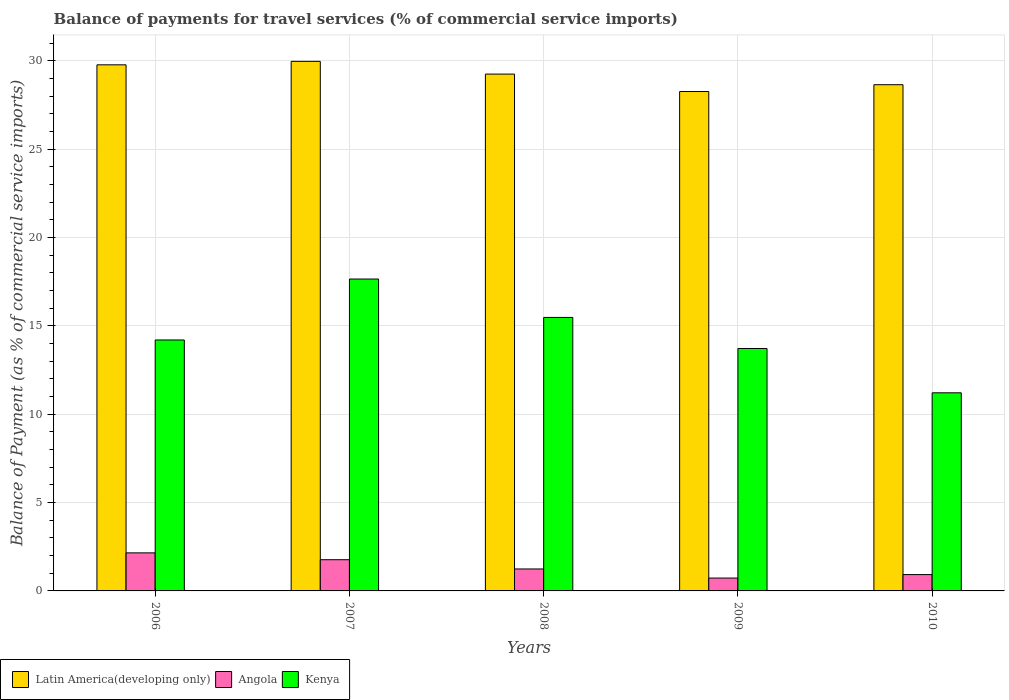Are the number of bars per tick equal to the number of legend labels?
Your answer should be very brief. Yes. Are the number of bars on each tick of the X-axis equal?
Your response must be concise. Yes. How many bars are there on the 2nd tick from the right?
Provide a short and direct response. 3. What is the label of the 1st group of bars from the left?
Your answer should be compact. 2006. What is the balance of payments for travel services in Kenya in 2008?
Provide a short and direct response. 15.48. Across all years, what is the maximum balance of payments for travel services in Angola?
Your answer should be very brief. 2.15. Across all years, what is the minimum balance of payments for travel services in Latin America(developing only)?
Ensure brevity in your answer.  28.26. What is the total balance of payments for travel services in Angola in the graph?
Ensure brevity in your answer.  6.81. What is the difference between the balance of payments for travel services in Angola in 2008 and that in 2009?
Give a very brief answer. 0.51. What is the difference between the balance of payments for travel services in Latin America(developing only) in 2008 and the balance of payments for travel services in Kenya in 2010?
Your response must be concise. 18.04. What is the average balance of payments for travel services in Kenya per year?
Offer a very short reply. 14.45. In the year 2009, what is the difference between the balance of payments for travel services in Angola and balance of payments for travel services in Kenya?
Keep it short and to the point. -12.99. What is the ratio of the balance of payments for travel services in Angola in 2006 to that in 2008?
Keep it short and to the point. 1.73. Is the difference between the balance of payments for travel services in Angola in 2006 and 2009 greater than the difference between the balance of payments for travel services in Kenya in 2006 and 2009?
Ensure brevity in your answer.  Yes. What is the difference between the highest and the second highest balance of payments for travel services in Latin America(developing only)?
Offer a very short reply. 0.2. What is the difference between the highest and the lowest balance of payments for travel services in Kenya?
Keep it short and to the point. 6.44. In how many years, is the balance of payments for travel services in Kenya greater than the average balance of payments for travel services in Kenya taken over all years?
Offer a very short reply. 2. Is the sum of the balance of payments for travel services in Latin America(developing only) in 2006 and 2010 greater than the maximum balance of payments for travel services in Angola across all years?
Keep it short and to the point. Yes. What does the 3rd bar from the left in 2009 represents?
Your response must be concise. Kenya. What does the 3rd bar from the right in 2008 represents?
Ensure brevity in your answer.  Latin America(developing only). Are all the bars in the graph horizontal?
Give a very brief answer. No. Are the values on the major ticks of Y-axis written in scientific E-notation?
Keep it short and to the point. No. Does the graph contain grids?
Your answer should be very brief. Yes. How many legend labels are there?
Ensure brevity in your answer.  3. How are the legend labels stacked?
Make the answer very short. Horizontal. What is the title of the graph?
Ensure brevity in your answer.  Balance of payments for travel services (% of commercial service imports). Does "Equatorial Guinea" appear as one of the legend labels in the graph?
Offer a terse response. No. What is the label or title of the X-axis?
Offer a very short reply. Years. What is the label or title of the Y-axis?
Offer a very short reply. Balance of Payment (as % of commercial service imports). What is the Balance of Payment (as % of commercial service imports) in Latin America(developing only) in 2006?
Ensure brevity in your answer.  29.77. What is the Balance of Payment (as % of commercial service imports) of Angola in 2006?
Offer a very short reply. 2.15. What is the Balance of Payment (as % of commercial service imports) of Kenya in 2006?
Provide a short and direct response. 14.2. What is the Balance of Payment (as % of commercial service imports) in Latin America(developing only) in 2007?
Your answer should be very brief. 29.97. What is the Balance of Payment (as % of commercial service imports) of Angola in 2007?
Offer a very short reply. 1.77. What is the Balance of Payment (as % of commercial service imports) in Kenya in 2007?
Keep it short and to the point. 17.65. What is the Balance of Payment (as % of commercial service imports) in Latin America(developing only) in 2008?
Your response must be concise. 29.25. What is the Balance of Payment (as % of commercial service imports) in Angola in 2008?
Provide a succinct answer. 1.24. What is the Balance of Payment (as % of commercial service imports) in Kenya in 2008?
Your answer should be compact. 15.48. What is the Balance of Payment (as % of commercial service imports) of Latin America(developing only) in 2009?
Your answer should be very brief. 28.26. What is the Balance of Payment (as % of commercial service imports) of Angola in 2009?
Offer a terse response. 0.73. What is the Balance of Payment (as % of commercial service imports) of Kenya in 2009?
Offer a terse response. 13.72. What is the Balance of Payment (as % of commercial service imports) in Latin America(developing only) in 2010?
Provide a succinct answer. 28.65. What is the Balance of Payment (as % of commercial service imports) of Angola in 2010?
Your answer should be very brief. 0.92. What is the Balance of Payment (as % of commercial service imports) of Kenya in 2010?
Your response must be concise. 11.21. Across all years, what is the maximum Balance of Payment (as % of commercial service imports) in Latin America(developing only)?
Provide a short and direct response. 29.97. Across all years, what is the maximum Balance of Payment (as % of commercial service imports) of Angola?
Your answer should be very brief. 2.15. Across all years, what is the maximum Balance of Payment (as % of commercial service imports) in Kenya?
Make the answer very short. 17.65. Across all years, what is the minimum Balance of Payment (as % of commercial service imports) of Latin America(developing only)?
Keep it short and to the point. 28.26. Across all years, what is the minimum Balance of Payment (as % of commercial service imports) of Angola?
Give a very brief answer. 0.73. Across all years, what is the minimum Balance of Payment (as % of commercial service imports) of Kenya?
Offer a very short reply. 11.21. What is the total Balance of Payment (as % of commercial service imports) in Latin America(developing only) in the graph?
Offer a terse response. 145.89. What is the total Balance of Payment (as % of commercial service imports) of Angola in the graph?
Provide a short and direct response. 6.81. What is the total Balance of Payment (as % of commercial service imports) in Kenya in the graph?
Provide a short and direct response. 72.26. What is the difference between the Balance of Payment (as % of commercial service imports) in Latin America(developing only) in 2006 and that in 2007?
Keep it short and to the point. -0.2. What is the difference between the Balance of Payment (as % of commercial service imports) of Angola in 2006 and that in 2007?
Provide a succinct answer. 0.39. What is the difference between the Balance of Payment (as % of commercial service imports) of Kenya in 2006 and that in 2007?
Provide a short and direct response. -3.45. What is the difference between the Balance of Payment (as % of commercial service imports) in Latin America(developing only) in 2006 and that in 2008?
Your answer should be compact. 0.52. What is the difference between the Balance of Payment (as % of commercial service imports) of Angola in 2006 and that in 2008?
Give a very brief answer. 0.91. What is the difference between the Balance of Payment (as % of commercial service imports) in Kenya in 2006 and that in 2008?
Give a very brief answer. -1.28. What is the difference between the Balance of Payment (as % of commercial service imports) in Latin America(developing only) in 2006 and that in 2009?
Offer a very short reply. 1.51. What is the difference between the Balance of Payment (as % of commercial service imports) in Angola in 2006 and that in 2009?
Keep it short and to the point. 1.43. What is the difference between the Balance of Payment (as % of commercial service imports) of Kenya in 2006 and that in 2009?
Keep it short and to the point. 0.48. What is the difference between the Balance of Payment (as % of commercial service imports) of Latin America(developing only) in 2006 and that in 2010?
Offer a very short reply. 1.13. What is the difference between the Balance of Payment (as % of commercial service imports) of Angola in 2006 and that in 2010?
Keep it short and to the point. 1.23. What is the difference between the Balance of Payment (as % of commercial service imports) of Kenya in 2006 and that in 2010?
Make the answer very short. 2.99. What is the difference between the Balance of Payment (as % of commercial service imports) of Latin America(developing only) in 2007 and that in 2008?
Your answer should be compact. 0.72. What is the difference between the Balance of Payment (as % of commercial service imports) of Angola in 2007 and that in 2008?
Provide a short and direct response. 0.52. What is the difference between the Balance of Payment (as % of commercial service imports) in Kenya in 2007 and that in 2008?
Keep it short and to the point. 2.17. What is the difference between the Balance of Payment (as % of commercial service imports) in Latin America(developing only) in 2007 and that in 2009?
Give a very brief answer. 1.71. What is the difference between the Balance of Payment (as % of commercial service imports) of Angola in 2007 and that in 2009?
Give a very brief answer. 1.04. What is the difference between the Balance of Payment (as % of commercial service imports) in Kenya in 2007 and that in 2009?
Offer a very short reply. 3.93. What is the difference between the Balance of Payment (as % of commercial service imports) in Latin America(developing only) in 2007 and that in 2010?
Your answer should be compact. 1.32. What is the difference between the Balance of Payment (as % of commercial service imports) of Angola in 2007 and that in 2010?
Your response must be concise. 0.84. What is the difference between the Balance of Payment (as % of commercial service imports) in Kenya in 2007 and that in 2010?
Make the answer very short. 6.44. What is the difference between the Balance of Payment (as % of commercial service imports) of Angola in 2008 and that in 2009?
Your response must be concise. 0.51. What is the difference between the Balance of Payment (as % of commercial service imports) in Kenya in 2008 and that in 2009?
Your response must be concise. 1.76. What is the difference between the Balance of Payment (as % of commercial service imports) in Latin America(developing only) in 2008 and that in 2010?
Offer a very short reply. 0.6. What is the difference between the Balance of Payment (as % of commercial service imports) in Angola in 2008 and that in 2010?
Make the answer very short. 0.32. What is the difference between the Balance of Payment (as % of commercial service imports) of Kenya in 2008 and that in 2010?
Provide a succinct answer. 4.27. What is the difference between the Balance of Payment (as % of commercial service imports) of Latin America(developing only) in 2009 and that in 2010?
Ensure brevity in your answer.  -0.39. What is the difference between the Balance of Payment (as % of commercial service imports) in Angola in 2009 and that in 2010?
Provide a short and direct response. -0.2. What is the difference between the Balance of Payment (as % of commercial service imports) of Kenya in 2009 and that in 2010?
Your answer should be compact. 2.51. What is the difference between the Balance of Payment (as % of commercial service imports) of Latin America(developing only) in 2006 and the Balance of Payment (as % of commercial service imports) of Angola in 2007?
Make the answer very short. 28. What is the difference between the Balance of Payment (as % of commercial service imports) of Latin America(developing only) in 2006 and the Balance of Payment (as % of commercial service imports) of Kenya in 2007?
Your response must be concise. 12.12. What is the difference between the Balance of Payment (as % of commercial service imports) of Angola in 2006 and the Balance of Payment (as % of commercial service imports) of Kenya in 2007?
Your answer should be compact. -15.5. What is the difference between the Balance of Payment (as % of commercial service imports) in Latin America(developing only) in 2006 and the Balance of Payment (as % of commercial service imports) in Angola in 2008?
Offer a terse response. 28.53. What is the difference between the Balance of Payment (as % of commercial service imports) in Latin America(developing only) in 2006 and the Balance of Payment (as % of commercial service imports) in Kenya in 2008?
Offer a very short reply. 14.29. What is the difference between the Balance of Payment (as % of commercial service imports) in Angola in 2006 and the Balance of Payment (as % of commercial service imports) in Kenya in 2008?
Provide a short and direct response. -13.32. What is the difference between the Balance of Payment (as % of commercial service imports) in Latin America(developing only) in 2006 and the Balance of Payment (as % of commercial service imports) in Angola in 2009?
Provide a succinct answer. 29.04. What is the difference between the Balance of Payment (as % of commercial service imports) in Latin America(developing only) in 2006 and the Balance of Payment (as % of commercial service imports) in Kenya in 2009?
Make the answer very short. 16.05. What is the difference between the Balance of Payment (as % of commercial service imports) of Angola in 2006 and the Balance of Payment (as % of commercial service imports) of Kenya in 2009?
Offer a very short reply. -11.56. What is the difference between the Balance of Payment (as % of commercial service imports) of Latin America(developing only) in 2006 and the Balance of Payment (as % of commercial service imports) of Angola in 2010?
Your answer should be very brief. 28.85. What is the difference between the Balance of Payment (as % of commercial service imports) of Latin America(developing only) in 2006 and the Balance of Payment (as % of commercial service imports) of Kenya in 2010?
Your response must be concise. 18.56. What is the difference between the Balance of Payment (as % of commercial service imports) of Angola in 2006 and the Balance of Payment (as % of commercial service imports) of Kenya in 2010?
Provide a succinct answer. -9.06. What is the difference between the Balance of Payment (as % of commercial service imports) of Latin America(developing only) in 2007 and the Balance of Payment (as % of commercial service imports) of Angola in 2008?
Your answer should be compact. 28.72. What is the difference between the Balance of Payment (as % of commercial service imports) of Latin America(developing only) in 2007 and the Balance of Payment (as % of commercial service imports) of Kenya in 2008?
Ensure brevity in your answer.  14.49. What is the difference between the Balance of Payment (as % of commercial service imports) of Angola in 2007 and the Balance of Payment (as % of commercial service imports) of Kenya in 2008?
Your response must be concise. -13.71. What is the difference between the Balance of Payment (as % of commercial service imports) of Latin America(developing only) in 2007 and the Balance of Payment (as % of commercial service imports) of Angola in 2009?
Keep it short and to the point. 29.24. What is the difference between the Balance of Payment (as % of commercial service imports) of Latin America(developing only) in 2007 and the Balance of Payment (as % of commercial service imports) of Kenya in 2009?
Provide a succinct answer. 16.25. What is the difference between the Balance of Payment (as % of commercial service imports) of Angola in 2007 and the Balance of Payment (as % of commercial service imports) of Kenya in 2009?
Offer a terse response. -11.95. What is the difference between the Balance of Payment (as % of commercial service imports) in Latin America(developing only) in 2007 and the Balance of Payment (as % of commercial service imports) in Angola in 2010?
Offer a terse response. 29.04. What is the difference between the Balance of Payment (as % of commercial service imports) in Latin America(developing only) in 2007 and the Balance of Payment (as % of commercial service imports) in Kenya in 2010?
Make the answer very short. 18.76. What is the difference between the Balance of Payment (as % of commercial service imports) in Angola in 2007 and the Balance of Payment (as % of commercial service imports) in Kenya in 2010?
Keep it short and to the point. -9.44. What is the difference between the Balance of Payment (as % of commercial service imports) in Latin America(developing only) in 2008 and the Balance of Payment (as % of commercial service imports) in Angola in 2009?
Make the answer very short. 28.52. What is the difference between the Balance of Payment (as % of commercial service imports) of Latin America(developing only) in 2008 and the Balance of Payment (as % of commercial service imports) of Kenya in 2009?
Provide a short and direct response. 15.53. What is the difference between the Balance of Payment (as % of commercial service imports) of Angola in 2008 and the Balance of Payment (as % of commercial service imports) of Kenya in 2009?
Offer a very short reply. -12.48. What is the difference between the Balance of Payment (as % of commercial service imports) in Latin America(developing only) in 2008 and the Balance of Payment (as % of commercial service imports) in Angola in 2010?
Offer a terse response. 28.32. What is the difference between the Balance of Payment (as % of commercial service imports) of Latin America(developing only) in 2008 and the Balance of Payment (as % of commercial service imports) of Kenya in 2010?
Make the answer very short. 18.04. What is the difference between the Balance of Payment (as % of commercial service imports) in Angola in 2008 and the Balance of Payment (as % of commercial service imports) in Kenya in 2010?
Give a very brief answer. -9.97. What is the difference between the Balance of Payment (as % of commercial service imports) of Latin America(developing only) in 2009 and the Balance of Payment (as % of commercial service imports) of Angola in 2010?
Make the answer very short. 27.34. What is the difference between the Balance of Payment (as % of commercial service imports) of Latin America(developing only) in 2009 and the Balance of Payment (as % of commercial service imports) of Kenya in 2010?
Provide a succinct answer. 17.05. What is the difference between the Balance of Payment (as % of commercial service imports) in Angola in 2009 and the Balance of Payment (as % of commercial service imports) in Kenya in 2010?
Provide a succinct answer. -10.48. What is the average Balance of Payment (as % of commercial service imports) in Latin America(developing only) per year?
Keep it short and to the point. 29.18. What is the average Balance of Payment (as % of commercial service imports) in Angola per year?
Provide a short and direct response. 1.36. What is the average Balance of Payment (as % of commercial service imports) in Kenya per year?
Your answer should be compact. 14.45. In the year 2006, what is the difference between the Balance of Payment (as % of commercial service imports) of Latin America(developing only) and Balance of Payment (as % of commercial service imports) of Angola?
Provide a short and direct response. 27.62. In the year 2006, what is the difference between the Balance of Payment (as % of commercial service imports) in Latin America(developing only) and Balance of Payment (as % of commercial service imports) in Kenya?
Provide a succinct answer. 15.57. In the year 2006, what is the difference between the Balance of Payment (as % of commercial service imports) of Angola and Balance of Payment (as % of commercial service imports) of Kenya?
Offer a terse response. -12.05. In the year 2007, what is the difference between the Balance of Payment (as % of commercial service imports) in Latin America(developing only) and Balance of Payment (as % of commercial service imports) in Angola?
Your answer should be compact. 28.2. In the year 2007, what is the difference between the Balance of Payment (as % of commercial service imports) of Latin America(developing only) and Balance of Payment (as % of commercial service imports) of Kenya?
Give a very brief answer. 12.32. In the year 2007, what is the difference between the Balance of Payment (as % of commercial service imports) in Angola and Balance of Payment (as % of commercial service imports) in Kenya?
Your answer should be compact. -15.88. In the year 2008, what is the difference between the Balance of Payment (as % of commercial service imports) in Latin America(developing only) and Balance of Payment (as % of commercial service imports) in Angola?
Provide a succinct answer. 28. In the year 2008, what is the difference between the Balance of Payment (as % of commercial service imports) of Latin America(developing only) and Balance of Payment (as % of commercial service imports) of Kenya?
Keep it short and to the point. 13.77. In the year 2008, what is the difference between the Balance of Payment (as % of commercial service imports) in Angola and Balance of Payment (as % of commercial service imports) in Kenya?
Provide a succinct answer. -14.23. In the year 2009, what is the difference between the Balance of Payment (as % of commercial service imports) of Latin America(developing only) and Balance of Payment (as % of commercial service imports) of Angola?
Provide a succinct answer. 27.53. In the year 2009, what is the difference between the Balance of Payment (as % of commercial service imports) in Latin America(developing only) and Balance of Payment (as % of commercial service imports) in Kenya?
Your answer should be very brief. 14.54. In the year 2009, what is the difference between the Balance of Payment (as % of commercial service imports) of Angola and Balance of Payment (as % of commercial service imports) of Kenya?
Offer a very short reply. -12.99. In the year 2010, what is the difference between the Balance of Payment (as % of commercial service imports) of Latin America(developing only) and Balance of Payment (as % of commercial service imports) of Angola?
Offer a terse response. 27.72. In the year 2010, what is the difference between the Balance of Payment (as % of commercial service imports) in Latin America(developing only) and Balance of Payment (as % of commercial service imports) in Kenya?
Your answer should be compact. 17.43. In the year 2010, what is the difference between the Balance of Payment (as % of commercial service imports) of Angola and Balance of Payment (as % of commercial service imports) of Kenya?
Give a very brief answer. -10.29. What is the ratio of the Balance of Payment (as % of commercial service imports) in Angola in 2006 to that in 2007?
Ensure brevity in your answer.  1.22. What is the ratio of the Balance of Payment (as % of commercial service imports) in Kenya in 2006 to that in 2007?
Offer a terse response. 0.8. What is the ratio of the Balance of Payment (as % of commercial service imports) of Latin America(developing only) in 2006 to that in 2008?
Provide a short and direct response. 1.02. What is the ratio of the Balance of Payment (as % of commercial service imports) of Angola in 2006 to that in 2008?
Offer a very short reply. 1.73. What is the ratio of the Balance of Payment (as % of commercial service imports) of Kenya in 2006 to that in 2008?
Your answer should be very brief. 0.92. What is the ratio of the Balance of Payment (as % of commercial service imports) of Latin America(developing only) in 2006 to that in 2009?
Offer a very short reply. 1.05. What is the ratio of the Balance of Payment (as % of commercial service imports) of Angola in 2006 to that in 2009?
Provide a short and direct response. 2.96. What is the ratio of the Balance of Payment (as % of commercial service imports) of Kenya in 2006 to that in 2009?
Give a very brief answer. 1.04. What is the ratio of the Balance of Payment (as % of commercial service imports) in Latin America(developing only) in 2006 to that in 2010?
Your response must be concise. 1.04. What is the ratio of the Balance of Payment (as % of commercial service imports) in Angola in 2006 to that in 2010?
Give a very brief answer. 2.33. What is the ratio of the Balance of Payment (as % of commercial service imports) of Kenya in 2006 to that in 2010?
Ensure brevity in your answer.  1.27. What is the ratio of the Balance of Payment (as % of commercial service imports) in Latin America(developing only) in 2007 to that in 2008?
Offer a very short reply. 1.02. What is the ratio of the Balance of Payment (as % of commercial service imports) in Angola in 2007 to that in 2008?
Keep it short and to the point. 1.42. What is the ratio of the Balance of Payment (as % of commercial service imports) of Kenya in 2007 to that in 2008?
Offer a terse response. 1.14. What is the ratio of the Balance of Payment (as % of commercial service imports) in Latin America(developing only) in 2007 to that in 2009?
Provide a succinct answer. 1.06. What is the ratio of the Balance of Payment (as % of commercial service imports) of Angola in 2007 to that in 2009?
Make the answer very short. 2.43. What is the ratio of the Balance of Payment (as % of commercial service imports) in Kenya in 2007 to that in 2009?
Provide a short and direct response. 1.29. What is the ratio of the Balance of Payment (as % of commercial service imports) of Latin America(developing only) in 2007 to that in 2010?
Provide a short and direct response. 1.05. What is the ratio of the Balance of Payment (as % of commercial service imports) of Angola in 2007 to that in 2010?
Your answer should be very brief. 1.91. What is the ratio of the Balance of Payment (as % of commercial service imports) of Kenya in 2007 to that in 2010?
Offer a very short reply. 1.57. What is the ratio of the Balance of Payment (as % of commercial service imports) of Latin America(developing only) in 2008 to that in 2009?
Provide a short and direct response. 1.03. What is the ratio of the Balance of Payment (as % of commercial service imports) of Angola in 2008 to that in 2009?
Your answer should be compact. 1.71. What is the ratio of the Balance of Payment (as % of commercial service imports) of Kenya in 2008 to that in 2009?
Your answer should be very brief. 1.13. What is the ratio of the Balance of Payment (as % of commercial service imports) of Angola in 2008 to that in 2010?
Make the answer very short. 1.34. What is the ratio of the Balance of Payment (as % of commercial service imports) in Kenya in 2008 to that in 2010?
Keep it short and to the point. 1.38. What is the ratio of the Balance of Payment (as % of commercial service imports) in Latin America(developing only) in 2009 to that in 2010?
Offer a very short reply. 0.99. What is the ratio of the Balance of Payment (as % of commercial service imports) of Angola in 2009 to that in 2010?
Give a very brief answer. 0.79. What is the ratio of the Balance of Payment (as % of commercial service imports) in Kenya in 2009 to that in 2010?
Make the answer very short. 1.22. What is the difference between the highest and the second highest Balance of Payment (as % of commercial service imports) of Latin America(developing only)?
Make the answer very short. 0.2. What is the difference between the highest and the second highest Balance of Payment (as % of commercial service imports) of Angola?
Your answer should be compact. 0.39. What is the difference between the highest and the second highest Balance of Payment (as % of commercial service imports) of Kenya?
Ensure brevity in your answer.  2.17. What is the difference between the highest and the lowest Balance of Payment (as % of commercial service imports) in Latin America(developing only)?
Provide a short and direct response. 1.71. What is the difference between the highest and the lowest Balance of Payment (as % of commercial service imports) in Angola?
Ensure brevity in your answer.  1.43. What is the difference between the highest and the lowest Balance of Payment (as % of commercial service imports) in Kenya?
Keep it short and to the point. 6.44. 